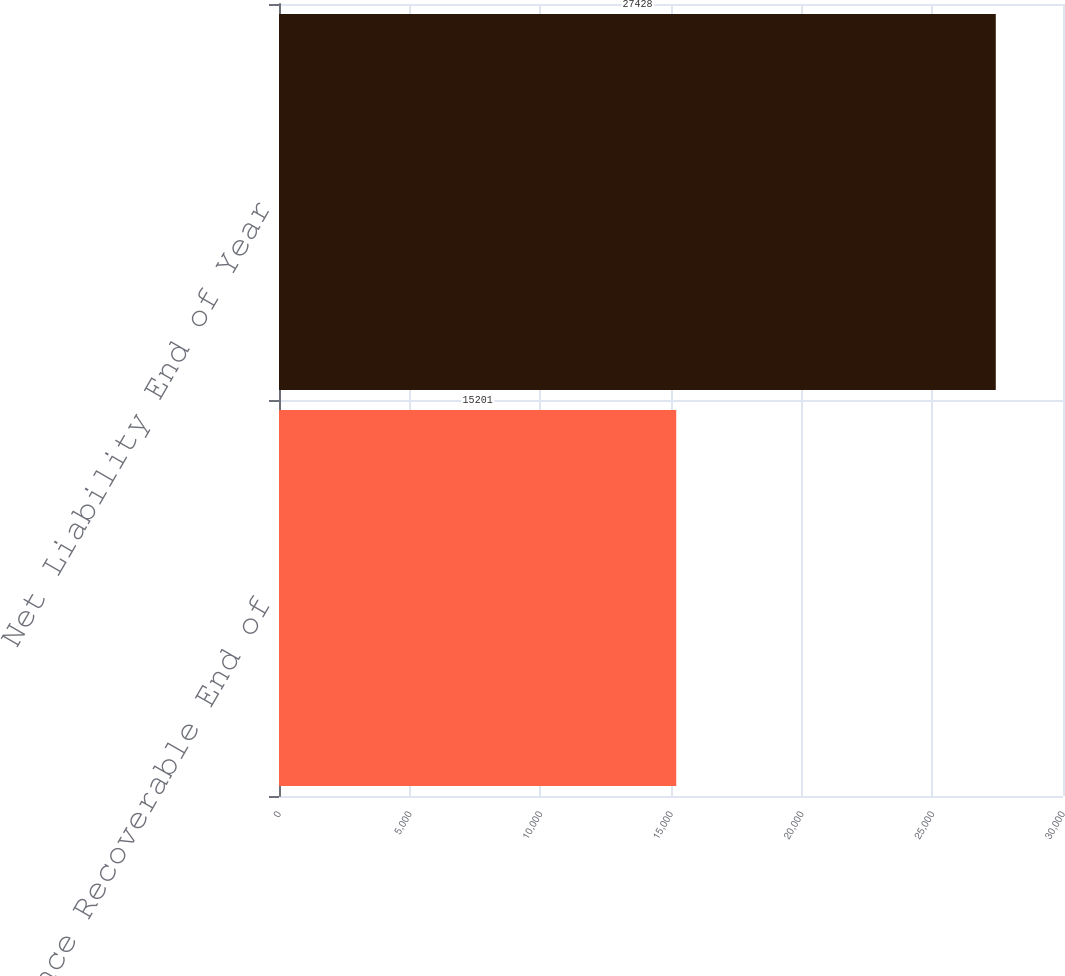Convert chart. <chart><loc_0><loc_0><loc_500><loc_500><bar_chart><fcel>Reinsurance Recoverable End of<fcel>Net Liability End of Year<nl><fcel>15201<fcel>27428<nl></chart> 